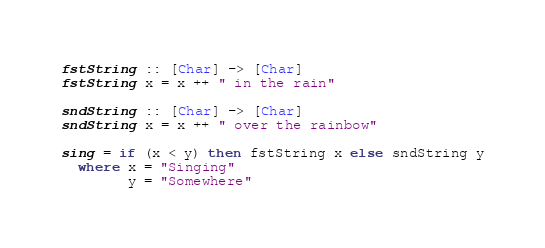<code> <loc_0><loc_0><loc_500><loc_500><_Haskell_>
fstString :: [Char] -> [Char]
fstString x = x ++ " in the rain"

sndString :: [Char] -> [Char]
sndString x = x ++ " over the rainbow"

sing = if (x < y) then fstString x else sndString y
  where x = "Singing"
        y = "Somewhere"
</code> 